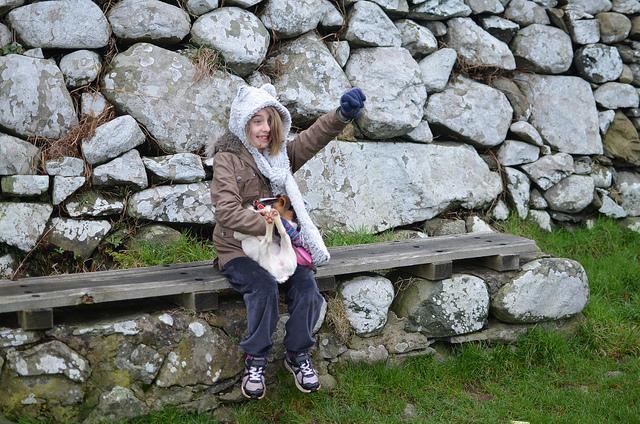What does the girl hold?
Answer the question by selecting the correct answer among the 4 following choices.
Options: Rabbit, dog, teddy bear, rat. Dog. What is it called when walls are built without mortar?
Answer the question by selecting the correct answer among the 4 following choices.
Options: Dry stone, rubble, neolithic, stack. Dry stone. 